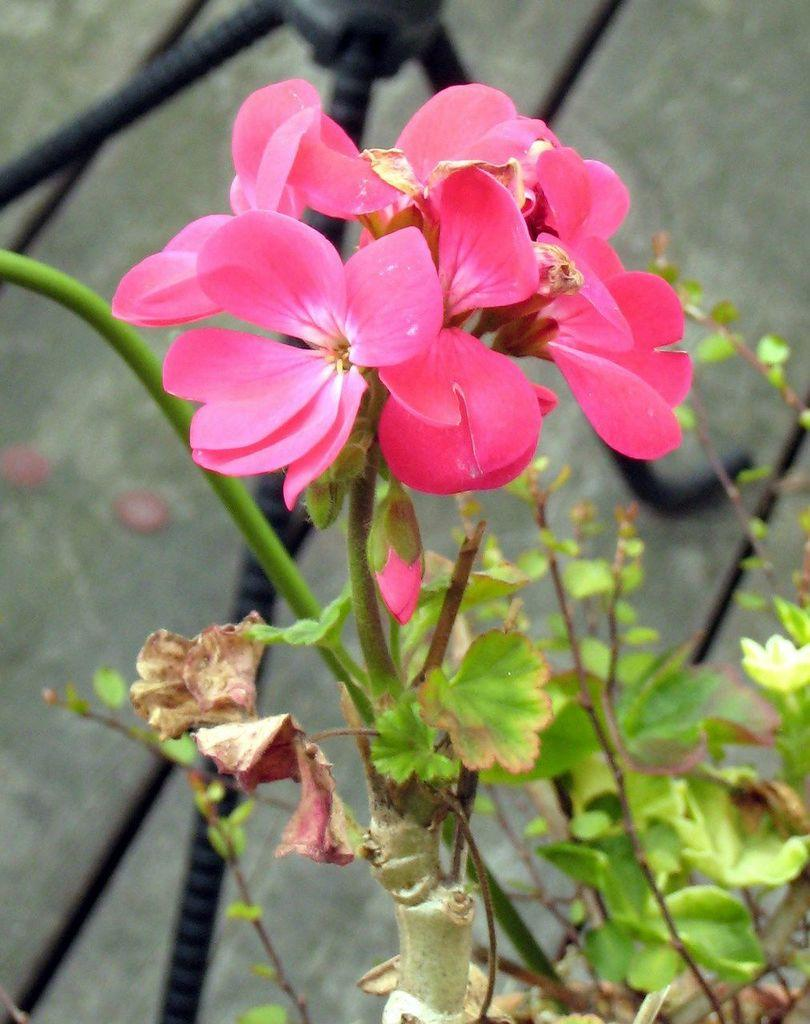What type of plant elements can be seen in the image? There are flowers, leaves, and stems in the image. Can you describe the arrangement of these plant elements? The flowers, leaves, and stems are likely arranged together, possibly as part of a bouquet or arrangement. What is visible in the background of the image? There appears to be an iron stand in the background of the image. What type of roof can be seen on the flowers in the image? There is no roof present in the image, as the subject is plant elements such as flowers, leaves, and stems. 